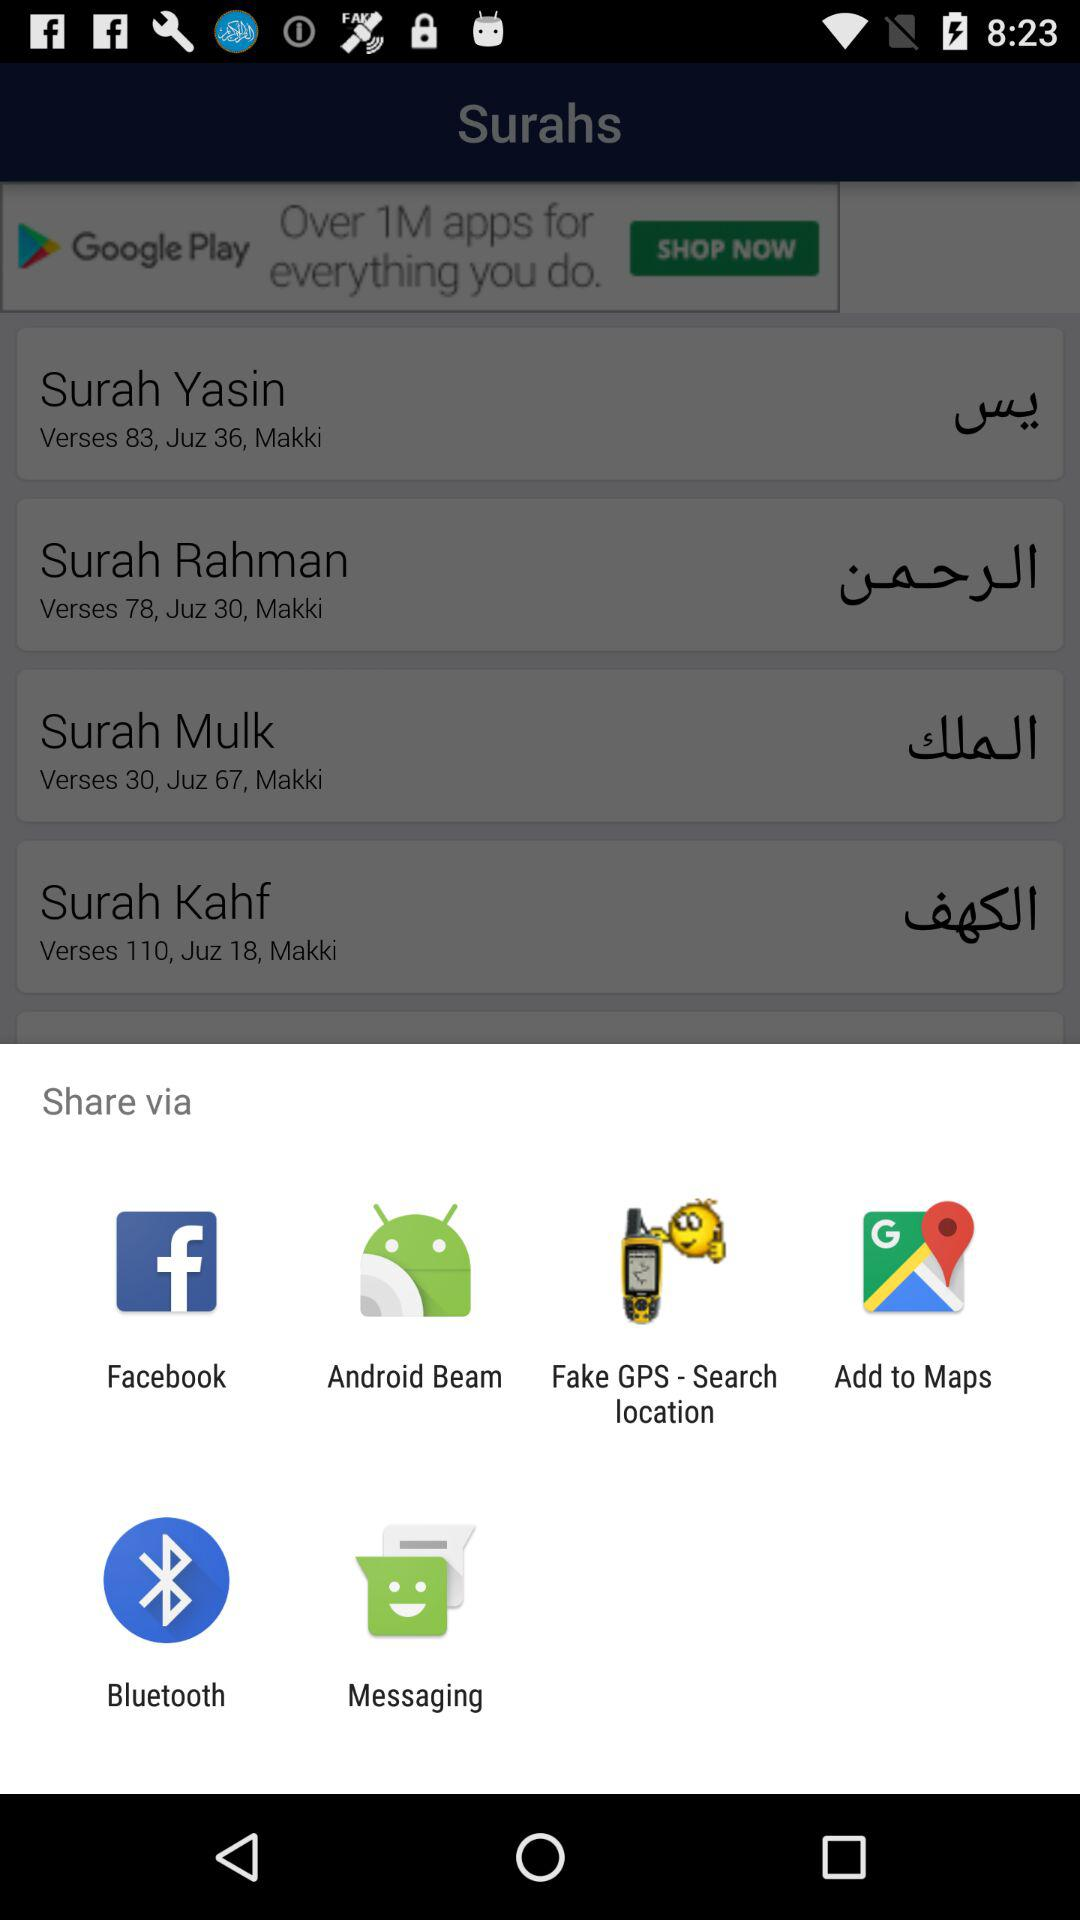Which Surah has 111 verses?
When the provided information is insufficient, respond with <no answer>. <no answer> 